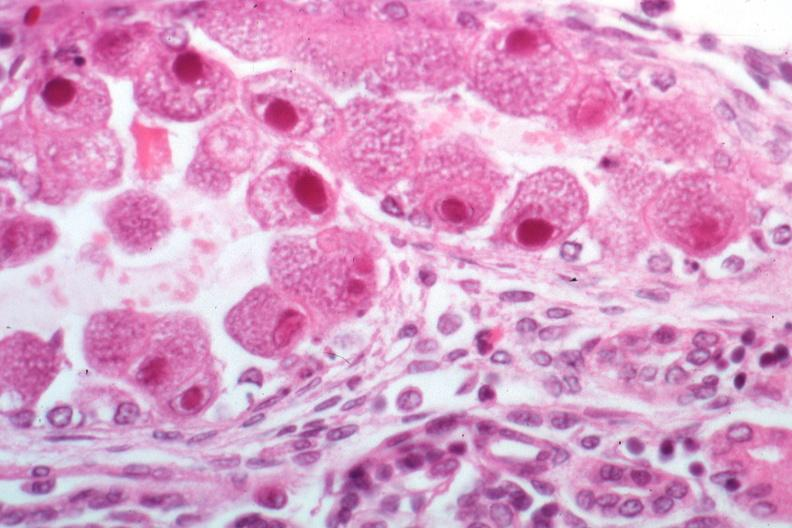s kidney present?
Answer the question using a single word or phrase. Yes 